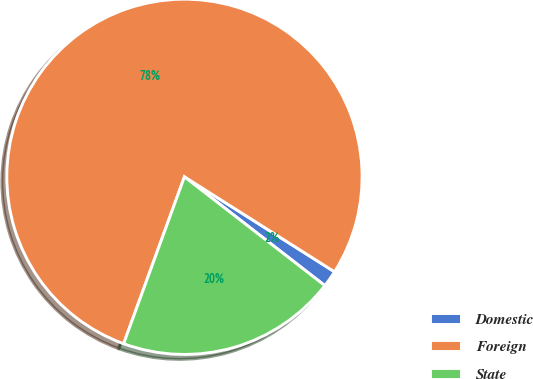Convert chart to OTSL. <chart><loc_0><loc_0><loc_500><loc_500><pie_chart><fcel>Domestic<fcel>Foreign<fcel>State<nl><fcel>1.51%<fcel>78.42%<fcel>20.07%<nl></chart> 